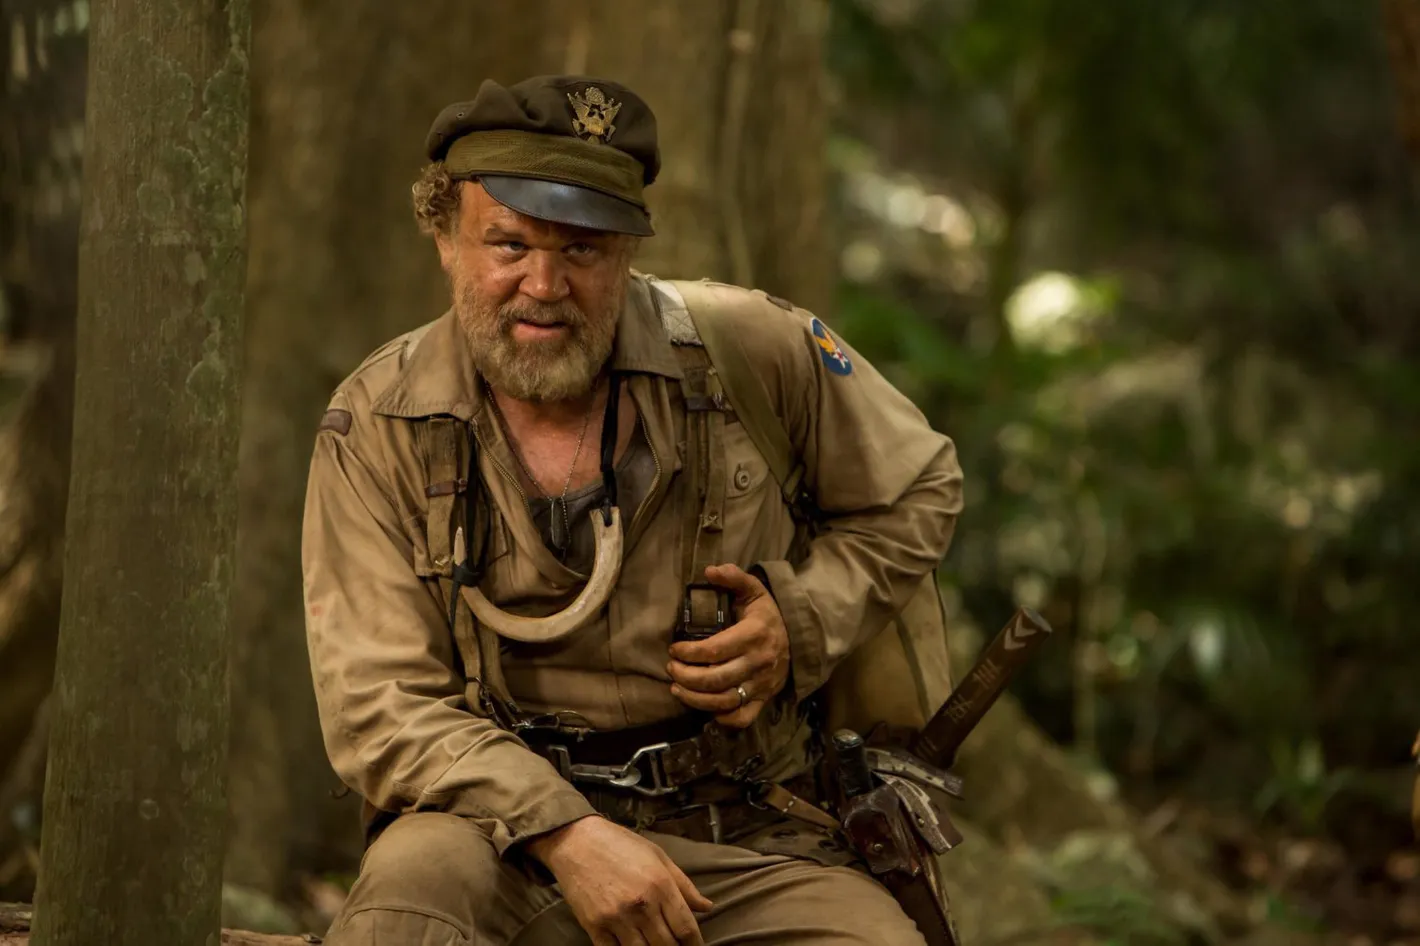Let's dive into a more imaginative scenario: What if the character discovers that the jungle is sentient and communicates with him? In this imaginative scenario, the character discovers that the jungle itself is sentient and begins communicating with him in subtle, mysterious ways. At first, he notices patterns in the rustling leaves and the way animals behave around him. Gradually, the messages become clearer, perhaps through dreams or hallucinations induced by the environment's unique flora. The jungle might start guiding him towards certain paths, offering protection and revealing hidden resources when he needs them most. As he delves deeper into this supernatural bond, he learns that the jungle has its own consciousness, shaped by centuries of history and ancient spirits. This revelation transforms his journey into a symbiotic relationship with the environment, where he must balance respect and understanding of the jungle's will with his own goals and survival instincts. The character becomes a guardian of the jungle, tasked with preserving its secrets and ensuring its protection from external threats. 